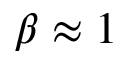<formula> <loc_0><loc_0><loc_500><loc_500>\beta \approx 1</formula> 